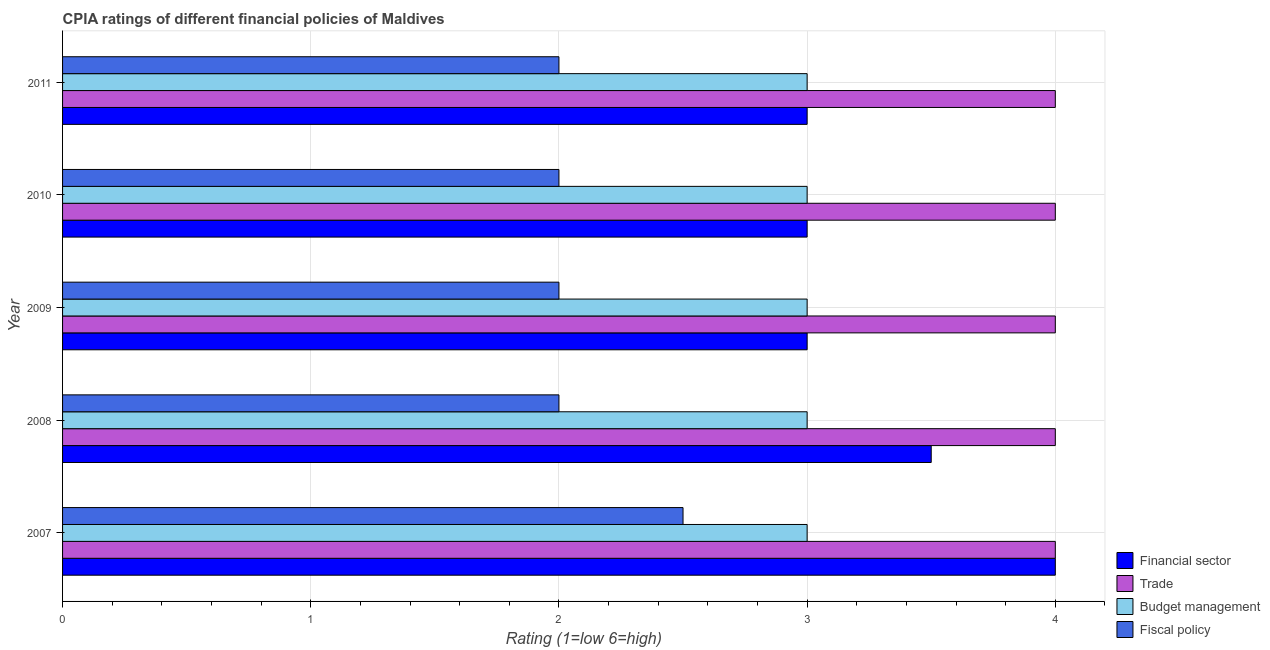How many different coloured bars are there?
Give a very brief answer. 4. Are the number of bars on each tick of the Y-axis equal?
Offer a terse response. Yes. How many bars are there on the 5th tick from the top?
Keep it short and to the point. 4. In how many cases, is the number of bars for a given year not equal to the number of legend labels?
Give a very brief answer. 0. What is the cpia rating of trade in 2011?
Provide a succinct answer. 4. Across all years, what is the maximum cpia rating of fiscal policy?
Give a very brief answer. 2.5. Across all years, what is the minimum cpia rating of budget management?
Ensure brevity in your answer.  3. In which year was the cpia rating of fiscal policy minimum?
Your answer should be very brief. 2008. What is the difference between the cpia rating of trade in 2007 and that in 2011?
Ensure brevity in your answer.  0. What is the average cpia rating of trade per year?
Your answer should be very brief. 4. What is the ratio of the cpia rating of fiscal policy in 2007 to that in 2009?
Ensure brevity in your answer.  1.25. Is the cpia rating of budget management in 2009 less than that in 2010?
Offer a very short reply. No. Is the difference between the cpia rating of trade in 2009 and 2011 greater than the difference between the cpia rating of financial sector in 2009 and 2011?
Give a very brief answer. No. What is the difference between the highest and the second highest cpia rating of budget management?
Ensure brevity in your answer.  0. In how many years, is the cpia rating of trade greater than the average cpia rating of trade taken over all years?
Ensure brevity in your answer.  0. Is the sum of the cpia rating of financial sector in 2009 and 2010 greater than the maximum cpia rating of fiscal policy across all years?
Make the answer very short. Yes. What does the 3rd bar from the top in 2007 represents?
Provide a succinct answer. Trade. What does the 4th bar from the bottom in 2010 represents?
Provide a short and direct response. Fiscal policy. Is it the case that in every year, the sum of the cpia rating of financial sector and cpia rating of trade is greater than the cpia rating of budget management?
Offer a very short reply. Yes. How many years are there in the graph?
Provide a short and direct response. 5. What is the difference between two consecutive major ticks on the X-axis?
Give a very brief answer. 1. Are the values on the major ticks of X-axis written in scientific E-notation?
Offer a very short reply. No. Does the graph contain grids?
Offer a very short reply. Yes. How many legend labels are there?
Your response must be concise. 4. How are the legend labels stacked?
Provide a short and direct response. Vertical. What is the title of the graph?
Offer a terse response. CPIA ratings of different financial policies of Maldives. What is the label or title of the X-axis?
Ensure brevity in your answer.  Rating (1=low 6=high). What is the Rating (1=low 6=high) in Trade in 2007?
Make the answer very short. 4. What is the Rating (1=low 6=high) of Budget management in 2007?
Provide a succinct answer. 3. What is the Rating (1=low 6=high) of Fiscal policy in 2007?
Make the answer very short. 2.5. What is the Rating (1=low 6=high) in Budget management in 2008?
Give a very brief answer. 3. What is the Rating (1=low 6=high) in Trade in 2009?
Your response must be concise. 4. What is the Rating (1=low 6=high) of Budget management in 2009?
Provide a short and direct response. 3. What is the Rating (1=low 6=high) in Budget management in 2010?
Offer a terse response. 3. What is the Rating (1=low 6=high) of Trade in 2011?
Keep it short and to the point. 4. What is the Rating (1=low 6=high) of Budget management in 2011?
Your answer should be very brief. 3. What is the Rating (1=low 6=high) of Fiscal policy in 2011?
Your answer should be compact. 2. Across all years, what is the maximum Rating (1=low 6=high) in Financial sector?
Your answer should be very brief. 4. Across all years, what is the minimum Rating (1=low 6=high) in Financial sector?
Make the answer very short. 3. Across all years, what is the minimum Rating (1=low 6=high) in Trade?
Give a very brief answer. 4. Across all years, what is the minimum Rating (1=low 6=high) in Budget management?
Your response must be concise. 3. What is the total Rating (1=low 6=high) in Fiscal policy in the graph?
Your answer should be very brief. 10.5. What is the difference between the Rating (1=low 6=high) of Financial sector in 2007 and that in 2008?
Keep it short and to the point. 0.5. What is the difference between the Rating (1=low 6=high) in Budget management in 2007 and that in 2008?
Your response must be concise. 0. What is the difference between the Rating (1=low 6=high) of Fiscal policy in 2007 and that in 2008?
Keep it short and to the point. 0.5. What is the difference between the Rating (1=low 6=high) in Financial sector in 2007 and that in 2009?
Make the answer very short. 1. What is the difference between the Rating (1=low 6=high) of Trade in 2007 and that in 2009?
Ensure brevity in your answer.  0. What is the difference between the Rating (1=low 6=high) of Budget management in 2007 and that in 2010?
Your answer should be very brief. 0. What is the difference between the Rating (1=low 6=high) of Financial sector in 2007 and that in 2011?
Your response must be concise. 1. What is the difference between the Rating (1=low 6=high) in Trade in 2007 and that in 2011?
Your answer should be compact. 0. What is the difference between the Rating (1=low 6=high) in Fiscal policy in 2008 and that in 2009?
Provide a succinct answer. 0. What is the difference between the Rating (1=low 6=high) of Trade in 2008 and that in 2010?
Offer a very short reply. 0. What is the difference between the Rating (1=low 6=high) in Budget management in 2008 and that in 2010?
Offer a very short reply. 0. What is the difference between the Rating (1=low 6=high) in Trade in 2008 and that in 2011?
Offer a very short reply. 0. What is the difference between the Rating (1=low 6=high) of Budget management in 2008 and that in 2011?
Your response must be concise. 0. What is the difference between the Rating (1=low 6=high) in Financial sector in 2009 and that in 2010?
Provide a succinct answer. 0. What is the difference between the Rating (1=low 6=high) of Fiscal policy in 2009 and that in 2010?
Give a very brief answer. 0. What is the difference between the Rating (1=low 6=high) in Financial sector in 2009 and that in 2011?
Ensure brevity in your answer.  0. What is the difference between the Rating (1=low 6=high) of Budget management in 2009 and that in 2011?
Your answer should be compact. 0. What is the difference between the Rating (1=low 6=high) of Budget management in 2010 and that in 2011?
Your response must be concise. 0. What is the difference between the Rating (1=low 6=high) in Financial sector in 2007 and the Rating (1=low 6=high) in Budget management in 2008?
Provide a succinct answer. 1. What is the difference between the Rating (1=low 6=high) of Trade in 2007 and the Rating (1=low 6=high) of Budget management in 2008?
Your response must be concise. 1. What is the difference between the Rating (1=low 6=high) of Trade in 2007 and the Rating (1=low 6=high) of Fiscal policy in 2008?
Provide a short and direct response. 2. What is the difference between the Rating (1=low 6=high) in Financial sector in 2007 and the Rating (1=low 6=high) in Fiscal policy in 2009?
Provide a short and direct response. 2. What is the difference between the Rating (1=low 6=high) of Trade in 2007 and the Rating (1=low 6=high) of Budget management in 2009?
Make the answer very short. 1. What is the difference between the Rating (1=low 6=high) in Trade in 2007 and the Rating (1=low 6=high) in Fiscal policy in 2009?
Offer a very short reply. 2. What is the difference between the Rating (1=low 6=high) of Financial sector in 2007 and the Rating (1=low 6=high) of Trade in 2010?
Offer a terse response. 0. What is the difference between the Rating (1=low 6=high) of Budget management in 2007 and the Rating (1=low 6=high) of Fiscal policy in 2010?
Provide a short and direct response. 1. What is the difference between the Rating (1=low 6=high) of Financial sector in 2007 and the Rating (1=low 6=high) of Trade in 2011?
Ensure brevity in your answer.  0. What is the difference between the Rating (1=low 6=high) in Financial sector in 2007 and the Rating (1=low 6=high) in Fiscal policy in 2011?
Provide a short and direct response. 2. What is the difference between the Rating (1=low 6=high) in Budget management in 2007 and the Rating (1=low 6=high) in Fiscal policy in 2011?
Your response must be concise. 1. What is the difference between the Rating (1=low 6=high) of Financial sector in 2008 and the Rating (1=low 6=high) of Trade in 2009?
Your answer should be very brief. -0.5. What is the difference between the Rating (1=low 6=high) in Financial sector in 2008 and the Rating (1=low 6=high) in Budget management in 2009?
Make the answer very short. 0.5. What is the difference between the Rating (1=low 6=high) of Financial sector in 2008 and the Rating (1=low 6=high) of Fiscal policy in 2009?
Your response must be concise. 1.5. What is the difference between the Rating (1=low 6=high) in Trade in 2008 and the Rating (1=low 6=high) in Fiscal policy in 2009?
Offer a terse response. 2. What is the difference between the Rating (1=low 6=high) in Financial sector in 2008 and the Rating (1=low 6=high) in Fiscal policy in 2010?
Your answer should be very brief. 1.5. What is the difference between the Rating (1=low 6=high) of Trade in 2008 and the Rating (1=low 6=high) of Fiscal policy in 2010?
Offer a terse response. 2. What is the difference between the Rating (1=low 6=high) of Budget management in 2008 and the Rating (1=low 6=high) of Fiscal policy in 2010?
Ensure brevity in your answer.  1. What is the difference between the Rating (1=low 6=high) in Financial sector in 2008 and the Rating (1=low 6=high) in Trade in 2011?
Your answer should be very brief. -0.5. What is the difference between the Rating (1=low 6=high) of Financial sector in 2008 and the Rating (1=low 6=high) of Budget management in 2011?
Give a very brief answer. 0.5. What is the difference between the Rating (1=low 6=high) in Financial sector in 2008 and the Rating (1=low 6=high) in Fiscal policy in 2011?
Provide a succinct answer. 1.5. What is the difference between the Rating (1=low 6=high) in Budget management in 2008 and the Rating (1=low 6=high) in Fiscal policy in 2011?
Provide a succinct answer. 1. What is the difference between the Rating (1=low 6=high) of Financial sector in 2009 and the Rating (1=low 6=high) of Trade in 2010?
Your answer should be compact. -1. What is the difference between the Rating (1=low 6=high) in Financial sector in 2009 and the Rating (1=low 6=high) in Budget management in 2010?
Provide a short and direct response. 0. What is the difference between the Rating (1=low 6=high) of Trade in 2009 and the Rating (1=low 6=high) of Budget management in 2010?
Keep it short and to the point. 1. What is the difference between the Rating (1=low 6=high) of Budget management in 2009 and the Rating (1=low 6=high) of Fiscal policy in 2010?
Give a very brief answer. 1. What is the difference between the Rating (1=low 6=high) of Financial sector in 2009 and the Rating (1=low 6=high) of Budget management in 2011?
Ensure brevity in your answer.  0. What is the difference between the Rating (1=low 6=high) of Financial sector in 2009 and the Rating (1=low 6=high) of Fiscal policy in 2011?
Offer a terse response. 1. What is the difference between the Rating (1=low 6=high) in Budget management in 2009 and the Rating (1=low 6=high) in Fiscal policy in 2011?
Your response must be concise. 1. What is the difference between the Rating (1=low 6=high) in Financial sector in 2010 and the Rating (1=low 6=high) in Fiscal policy in 2011?
Keep it short and to the point. 1. What is the difference between the Rating (1=low 6=high) in Trade in 2010 and the Rating (1=low 6=high) in Budget management in 2011?
Offer a very short reply. 1. What is the difference between the Rating (1=low 6=high) in Trade in 2010 and the Rating (1=low 6=high) in Fiscal policy in 2011?
Keep it short and to the point. 2. What is the average Rating (1=low 6=high) of Budget management per year?
Keep it short and to the point. 3. In the year 2007, what is the difference between the Rating (1=low 6=high) of Financial sector and Rating (1=low 6=high) of Fiscal policy?
Your answer should be compact. 1.5. In the year 2007, what is the difference between the Rating (1=low 6=high) of Budget management and Rating (1=low 6=high) of Fiscal policy?
Offer a very short reply. 0.5. In the year 2009, what is the difference between the Rating (1=low 6=high) of Financial sector and Rating (1=low 6=high) of Trade?
Ensure brevity in your answer.  -1. In the year 2009, what is the difference between the Rating (1=low 6=high) in Financial sector and Rating (1=low 6=high) in Budget management?
Make the answer very short. 0. In the year 2009, what is the difference between the Rating (1=low 6=high) in Budget management and Rating (1=low 6=high) in Fiscal policy?
Your answer should be very brief. 1. In the year 2010, what is the difference between the Rating (1=low 6=high) in Financial sector and Rating (1=low 6=high) in Trade?
Your response must be concise. -1. In the year 2010, what is the difference between the Rating (1=low 6=high) of Financial sector and Rating (1=low 6=high) of Budget management?
Keep it short and to the point. 0. In the year 2010, what is the difference between the Rating (1=low 6=high) of Financial sector and Rating (1=low 6=high) of Fiscal policy?
Offer a terse response. 1. In the year 2010, what is the difference between the Rating (1=low 6=high) of Budget management and Rating (1=low 6=high) of Fiscal policy?
Provide a short and direct response. 1. In the year 2011, what is the difference between the Rating (1=low 6=high) of Financial sector and Rating (1=low 6=high) of Trade?
Ensure brevity in your answer.  -1. In the year 2011, what is the difference between the Rating (1=low 6=high) in Financial sector and Rating (1=low 6=high) in Budget management?
Offer a terse response. 0. In the year 2011, what is the difference between the Rating (1=low 6=high) in Financial sector and Rating (1=low 6=high) in Fiscal policy?
Provide a succinct answer. 1. In the year 2011, what is the difference between the Rating (1=low 6=high) in Trade and Rating (1=low 6=high) in Budget management?
Make the answer very short. 1. In the year 2011, what is the difference between the Rating (1=low 6=high) of Trade and Rating (1=low 6=high) of Fiscal policy?
Make the answer very short. 2. In the year 2011, what is the difference between the Rating (1=low 6=high) of Budget management and Rating (1=low 6=high) of Fiscal policy?
Your answer should be compact. 1. What is the ratio of the Rating (1=low 6=high) in Trade in 2007 to that in 2008?
Give a very brief answer. 1. What is the ratio of the Rating (1=low 6=high) of Financial sector in 2007 to that in 2009?
Make the answer very short. 1.33. What is the ratio of the Rating (1=low 6=high) of Fiscal policy in 2007 to that in 2010?
Offer a very short reply. 1.25. What is the ratio of the Rating (1=low 6=high) of Financial sector in 2007 to that in 2011?
Make the answer very short. 1.33. What is the ratio of the Rating (1=low 6=high) in Budget management in 2008 to that in 2009?
Give a very brief answer. 1. What is the ratio of the Rating (1=low 6=high) in Fiscal policy in 2008 to that in 2009?
Make the answer very short. 1. What is the ratio of the Rating (1=low 6=high) of Financial sector in 2008 to that in 2010?
Provide a short and direct response. 1.17. What is the ratio of the Rating (1=low 6=high) in Trade in 2008 to that in 2010?
Ensure brevity in your answer.  1. What is the ratio of the Rating (1=low 6=high) in Financial sector in 2008 to that in 2011?
Your answer should be compact. 1.17. What is the ratio of the Rating (1=low 6=high) in Fiscal policy in 2008 to that in 2011?
Your answer should be compact. 1. What is the ratio of the Rating (1=low 6=high) in Financial sector in 2009 to that in 2010?
Your answer should be compact. 1. What is the ratio of the Rating (1=low 6=high) in Trade in 2009 to that in 2010?
Provide a succinct answer. 1. What is the ratio of the Rating (1=low 6=high) of Budget management in 2009 to that in 2011?
Give a very brief answer. 1. What is the ratio of the Rating (1=low 6=high) of Financial sector in 2010 to that in 2011?
Your answer should be compact. 1. What is the ratio of the Rating (1=low 6=high) in Budget management in 2010 to that in 2011?
Ensure brevity in your answer.  1. What is the ratio of the Rating (1=low 6=high) of Fiscal policy in 2010 to that in 2011?
Offer a very short reply. 1. What is the difference between the highest and the second highest Rating (1=low 6=high) of Financial sector?
Keep it short and to the point. 0.5. What is the difference between the highest and the second highest Rating (1=low 6=high) of Trade?
Your response must be concise. 0. What is the difference between the highest and the second highest Rating (1=low 6=high) of Budget management?
Offer a very short reply. 0. What is the difference between the highest and the second highest Rating (1=low 6=high) in Fiscal policy?
Offer a terse response. 0.5. What is the difference between the highest and the lowest Rating (1=low 6=high) of Budget management?
Keep it short and to the point. 0. 